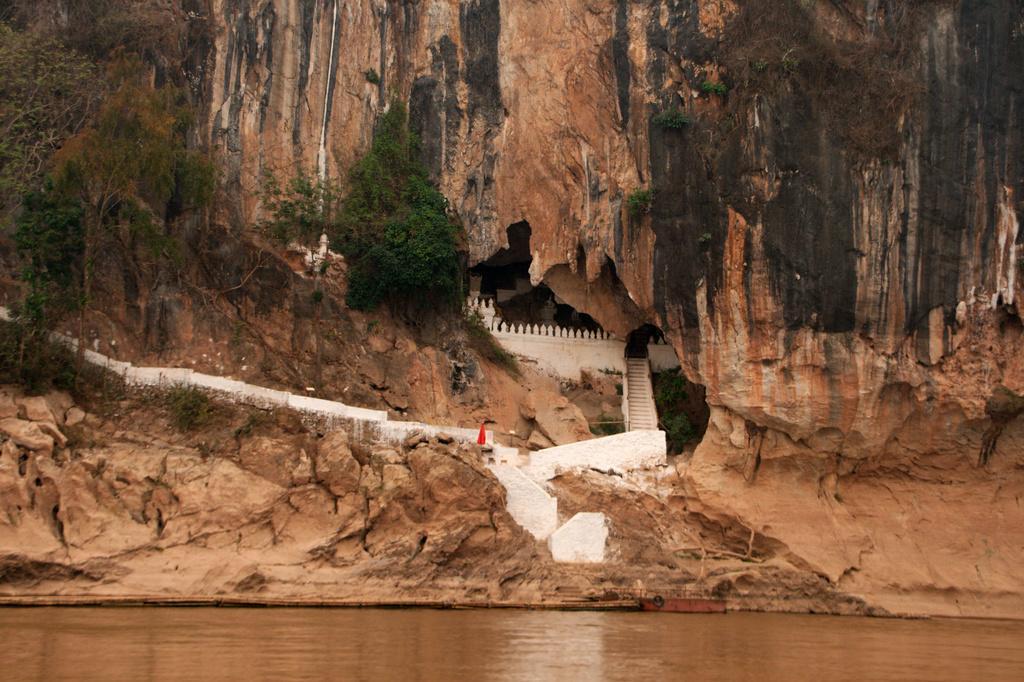Describe this image in one or two sentences. In the image there is a lake in the front and behind there is a mountain with steps in the middle and trees on the left side of it. 